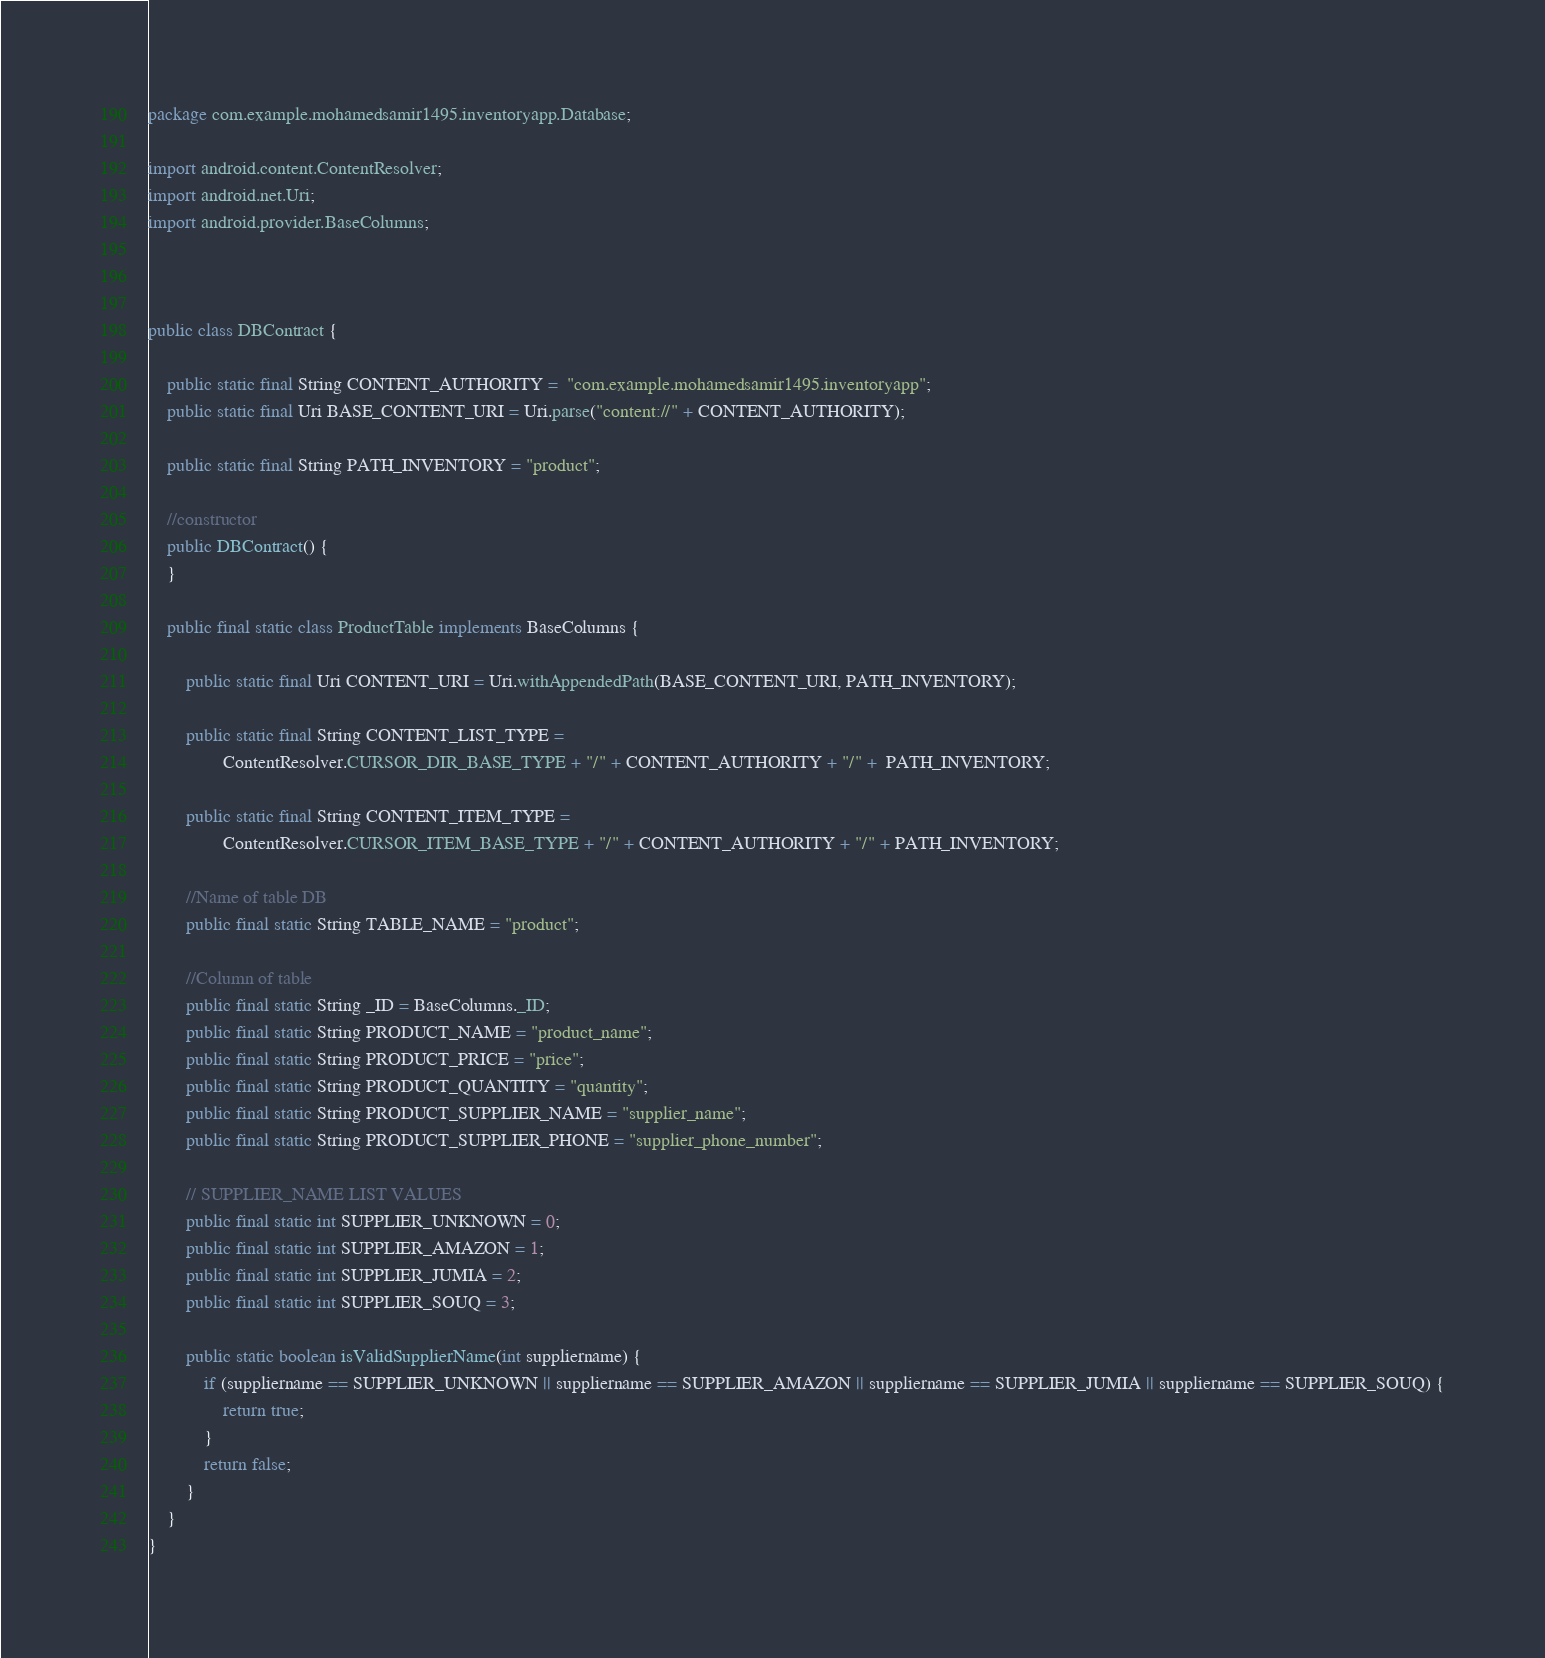<code> <loc_0><loc_0><loc_500><loc_500><_Java_>package com.example.mohamedsamir1495.inventoryapp.Database;

import android.content.ContentResolver;
import android.net.Uri;
import android.provider.BaseColumns;



public class DBContract {

    public static final String CONTENT_AUTHORITY =  "com.example.mohamedsamir1495.inventoryapp";
    public static final Uri BASE_CONTENT_URI = Uri.parse("content://" + CONTENT_AUTHORITY);

    public static final String PATH_INVENTORY = "product";

    //constructor
    public DBContract() {
    }

    public final static class ProductTable implements BaseColumns {

        public static final Uri CONTENT_URI = Uri.withAppendedPath(BASE_CONTENT_URI, PATH_INVENTORY);

        public static final String CONTENT_LIST_TYPE =
                ContentResolver.CURSOR_DIR_BASE_TYPE + "/" + CONTENT_AUTHORITY + "/" +  PATH_INVENTORY;

        public static final String CONTENT_ITEM_TYPE =
                ContentResolver.CURSOR_ITEM_BASE_TYPE + "/" + CONTENT_AUTHORITY + "/" + PATH_INVENTORY;

        //Name of table DB
        public final static String TABLE_NAME = "product";

        //Column of table
        public final static String _ID = BaseColumns._ID;
        public final static String PRODUCT_NAME = "product_name";
        public final static String PRODUCT_PRICE = "price";
        public final static String PRODUCT_QUANTITY = "quantity";
        public final static String PRODUCT_SUPPLIER_NAME = "supplier_name";
        public final static String PRODUCT_SUPPLIER_PHONE = "supplier_phone_number";

        // SUPPLIER_NAME LIST VALUES
        public final static int SUPPLIER_UNKNOWN = 0;
        public final static int SUPPLIER_AMAZON = 1;
        public final static int SUPPLIER_JUMIA = 2;
        public final static int SUPPLIER_SOUQ = 3;

        public static boolean isValidSupplierName(int suppliername) {
            if (suppliername == SUPPLIER_UNKNOWN || suppliername == SUPPLIER_AMAZON || suppliername == SUPPLIER_JUMIA || suppliername == SUPPLIER_SOUQ) {
                return true;
            }
            return false;
        }
    }
}
</code> 